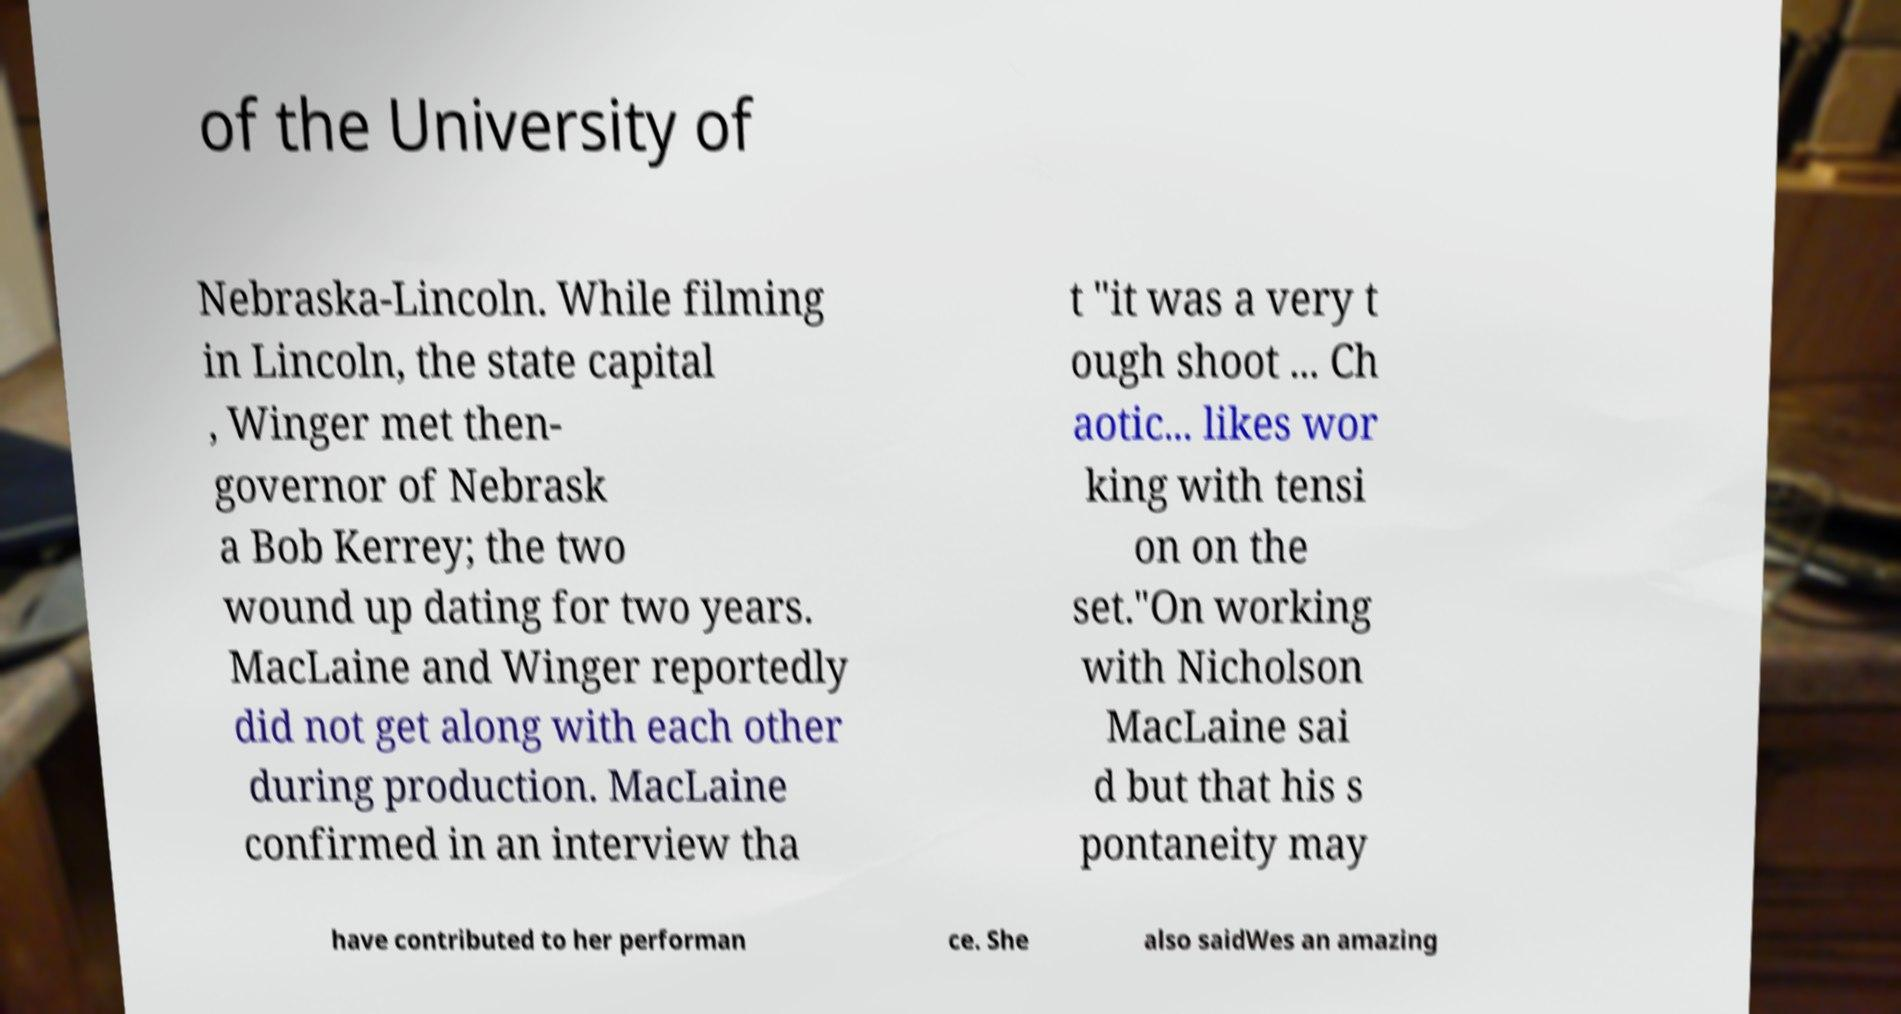Can you accurately transcribe the text from the provided image for me? of the University of Nebraska-Lincoln. While filming in Lincoln, the state capital , Winger met then- governor of Nebrask a Bob Kerrey; the two wound up dating for two years. MacLaine and Winger reportedly did not get along with each other during production. MacLaine confirmed in an interview tha t "it was a very t ough shoot ... Ch aotic... likes wor king with tensi on on the set."On working with Nicholson MacLaine sai d but that his s pontaneity may have contributed to her performan ce. She also saidWes an amazing 